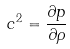Convert formula to latex. <formula><loc_0><loc_0><loc_500><loc_500>c ^ { 2 } = \frac { \partial p } { \partial \rho }</formula> 